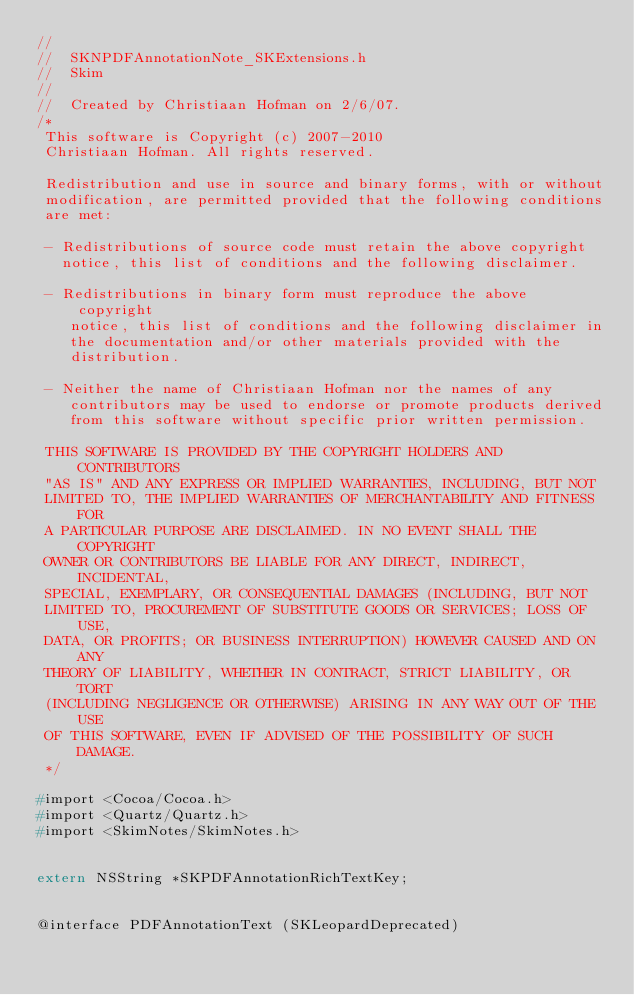Convert code to text. <code><loc_0><loc_0><loc_500><loc_500><_C_>//
//  SKNPDFAnnotationNote_SKExtensions.h
//  Skim
//
//  Created by Christiaan Hofman on 2/6/07.
/*
 This software is Copyright (c) 2007-2010
 Christiaan Hofman. All rights reserved.

 Redistribution and use in source and binary forms, with or without
 modification, are permitted provided that the following conditions
 are met:

 - Redistributions of source code must retain the above copyright
   notice, this list of conditions and the following disclaimer.

 - Redistributions in binary form must reproduce the above copyright
    notice, this list of conditions and the following disclaimer in
    the documentation and/or other materials provided with the
    distribution.

 - Neither the name of Christiaan Hofman nor the names of any
    contributors may be used to endorse or promote products derived
    from this software without specific prior written permission.

 THIS SOFTWARE IS PROVIDED BY THE COPYRIGHT HOLDERS AND CONTRIBUTORS
 "AS IS" AND ANY EXPRESS OR IMPLIED WARRANTIES, INCLUDING, BUT NOT
 LIMITED TO, THE IMPLIED WARRANTIES OF MERCHANTABILITY AND FITNESS FOR
 A PARTICULAR PURPOSE ARE DISCLAIMED. IN NO EVENT SHALL THE COPYRIGHT
 OWNER OR CONTRIBUTORS BE LIABLE FOR ANY DIRECT, INDIRECT, INCIDENTAL,
 SPECIAL, EXEMPLARY, OR CONSEQUENTIAL DAMAGES (INCLUDING, BUT NOT
 LIMITED TO, PROCUREMENT OF SUBSTITUTE GOODS OR SERVICES; LOSS OF USE,
 DATA, OR PROFITS; OR BUSINESS INTERRUPTION) HOWEVER CAUSED AND ON ANY
 THEORY OF LIABILITY, WHETHER IN CONTRACT, STRICT LIABILITY, OR TORT
 (INCLUDING NEGLIGENCE OR OTHERWISE) ARISING IN ANY WAY OUT OF THE USE
 OF THIS SOFTWARE, EVEN IF ADVISED OF THE POSSIBILITY OF SUCH DAMAGE.
 */

#import <Cocoa/Cocoa.h>
#import <Quartz/Quartz.h>
#import <SkimNotes/SkimNotes.h>


extern NSString *SKPDFAnnotationRichTextKey;


@interface PDFAnnotationText (SKLeopardDeprecated)</code> 